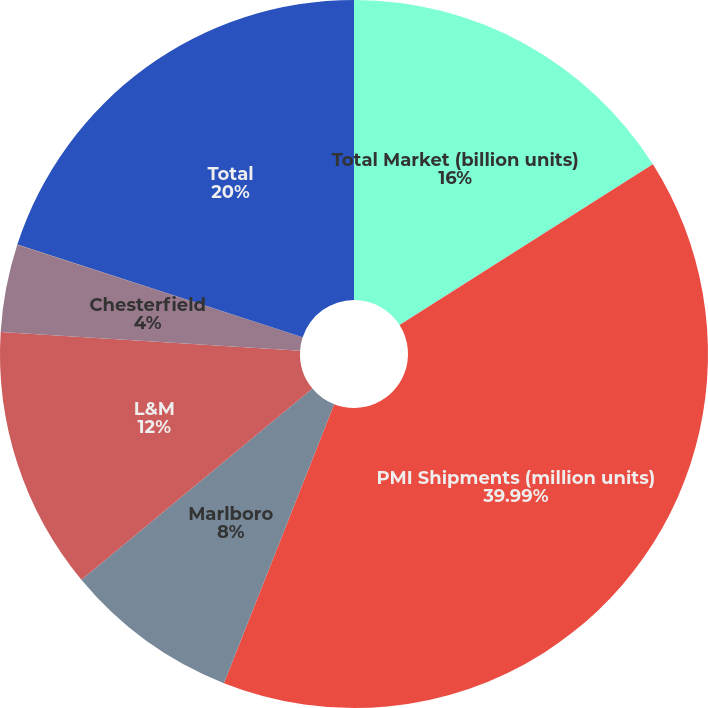<chart> <loc_0><loc_0><loc_500><loc_500><pie_chart><fcel>Total Market (billion units)<fcel>PMI Shipments (million units)<fcel>Marlboro<fcel>L&M<fcel>Chesterfield<fcel>Others<fcel>Total<nl><fcel>16.0%<fcel>39.99%<fcel>8.0%<fcel>12.0%<fcel>4.0%<fcel>0.01%<fcel>20.0%<nl></chart> 